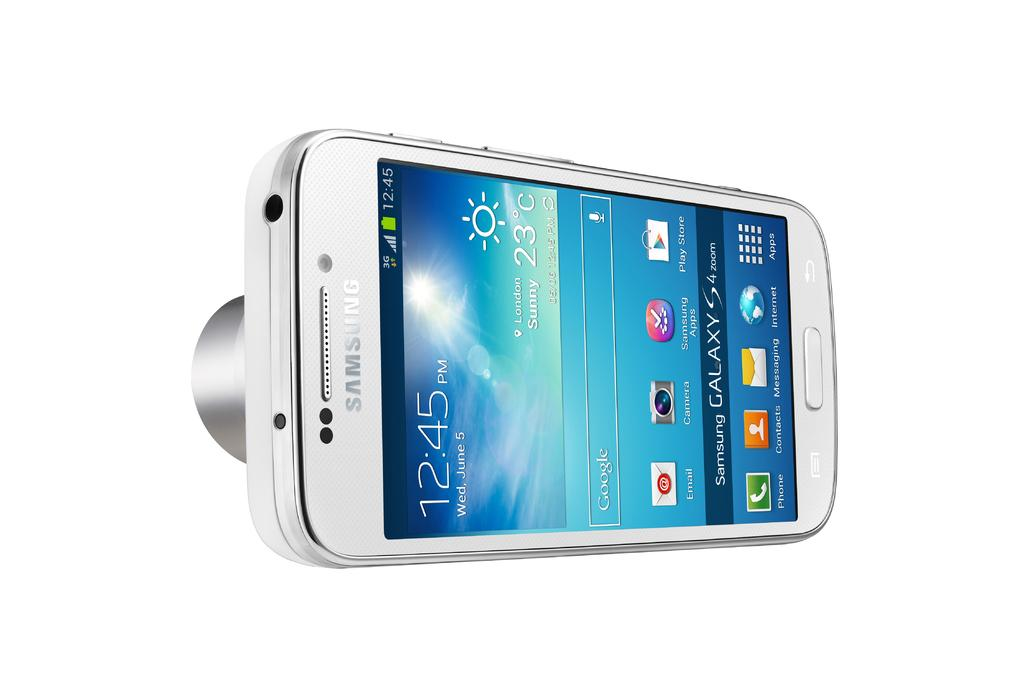<image>
Create a compact narrative representing the image presented. A Samsung Galaxy S 4 that is turned on and has the time 12:45 on it. 